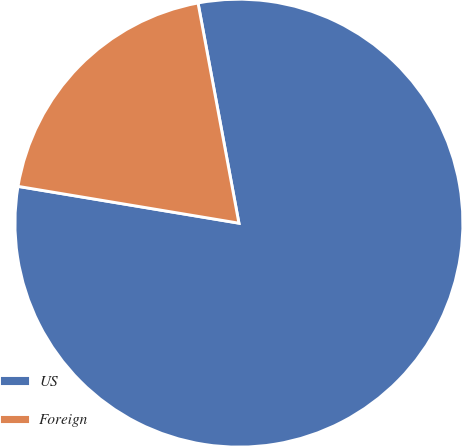<chart> <loc_0><loc_0><loc_500><loc_500><pie_chart><fcel>US<fcel>Foreign<nl><fcel>80.55%<fcel>19.45%<nl></chart> 